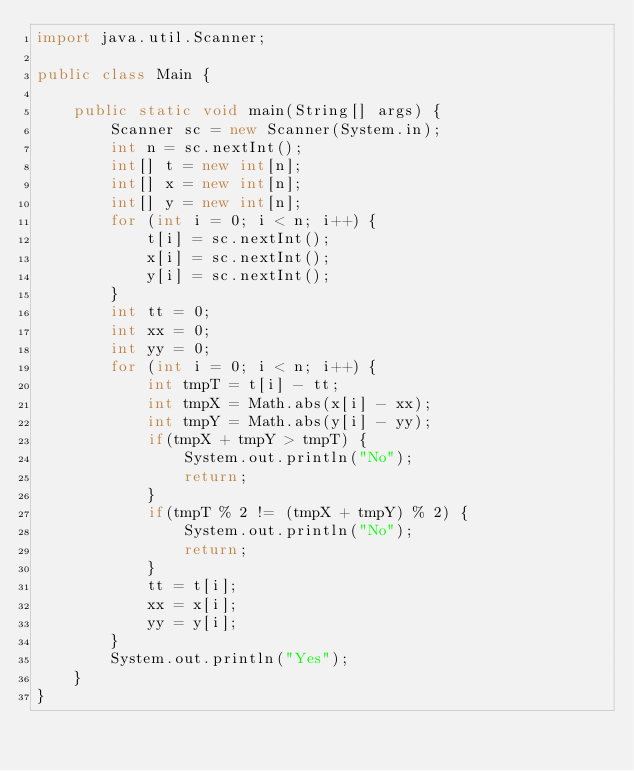Convert code to text. <code><loc_0><loc_0><loc_500><loc_500><_Java_>import java.util.Scanner;

public class Main {

    public static void main(String[] args) {
        Scanner sc = new Scanner(System.in);
        int n = sc.nextInt();
        int[] t = new int[n];
        int[] x = new int[n];
        int[] y = new int[n];
        for (int i = 0; i < n; i++) {
            t[i] = sc.nextInt();
            x[i] = sc.nextInt();
            y[i] = sc.nextInt();
        }
        int tt = 0;
        int xx = 0;
        int yy = 0;
        for (int i = 0; i < n; i++) {
            int tmpT = t[i] - tt;
            int tmpX = Math.abs(x[i] - xx);
            int tmpY = Math.abs(y[i] - yy);
            if(tmpX + tmpY > tmpT) {
                System.out.println("No");
                return;
            }
            if(tmpT % 2 != (tmpX + tmpY) % 2) {
                System.out.println("No");
                return;
            }
            tt = t[i];
            xx = x[i];
            yy = y[i];
        }
        System.out.println("Yes");
    }
}</code> 